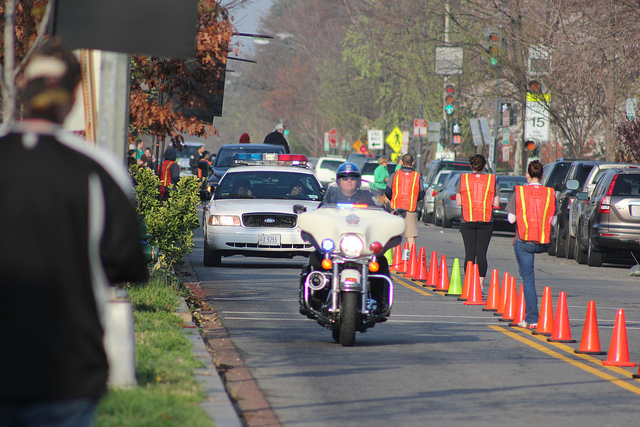What event might be taking place here? The image shows a road lined with orange cones and several people wearing reflective vests, suggesting that there might be a special event like a parade, marathon, or some sort of construction or maintenance work requiring traffic management. 